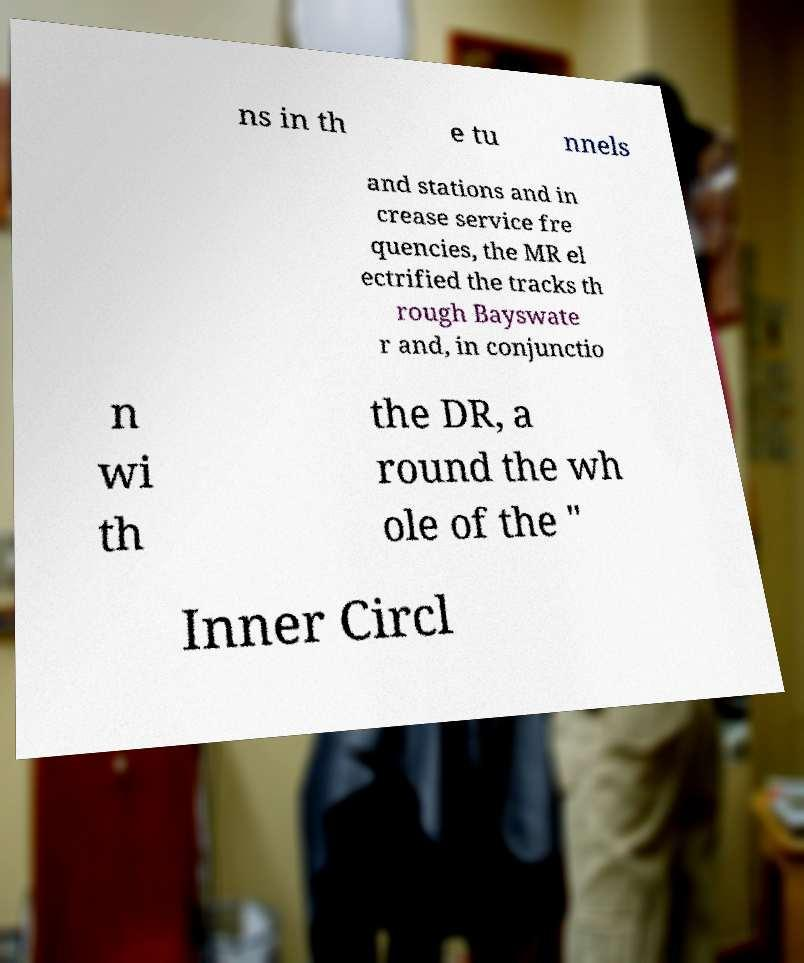There's text embedded in this image that I need extracted. Can you transcribe it verbatim? ns in th e tu nnels and stations and in crease service fre quencies, the MR el ectrified the tracks th rough Bayswate r and, in conjunctio n wi th the DR, a round the wh ole of the " Inner Circl 